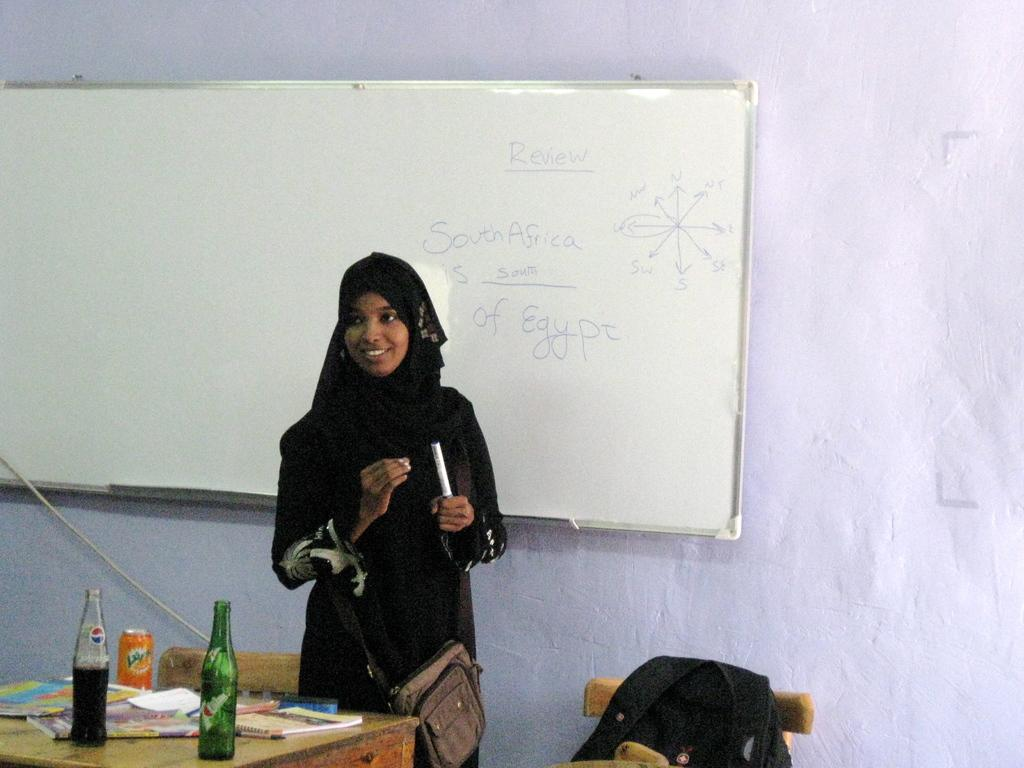What is the woman in the room doing? The woman is standing in the room. What is the woman wearing? The woman is wearing a Bukhara. What objects can be seen in the room? There is a board and a table in the room. What is on the table? There are cool drink bottles and books on the table. How many parcels can be seen on the woman's feet in the image? There are no parcels visible on the woman's feet in the image. What type of underwear is the woman wearing in the image? The provided facts do not mention the woman's underwear, so it cannot be determined from the image. 